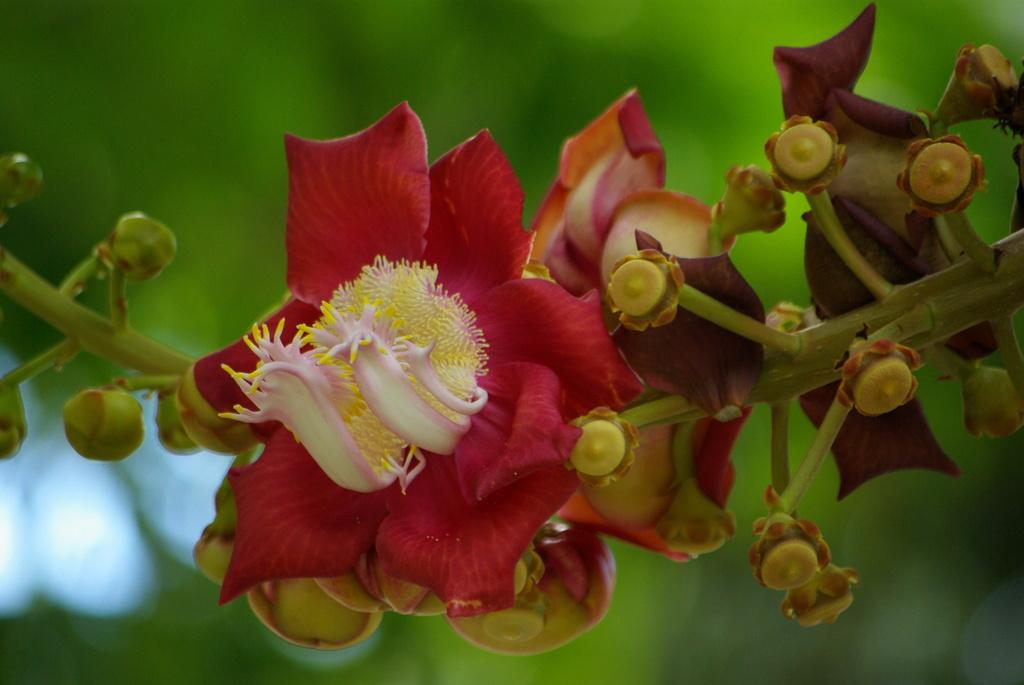What type of plants can be seen in the image? There are flowers in the image. What part of the flowers is visible in the image? There are stems in the image. What can be seen in the background of the image? There is greenery visible in the background of the image. What type of memory can be seen in the image? There is no memory present in the image; it features flowers, stems, and greenery. What type of corn can be seen growing in the image? There is no corn present in the image; it features flowers, stems, and greenery. 